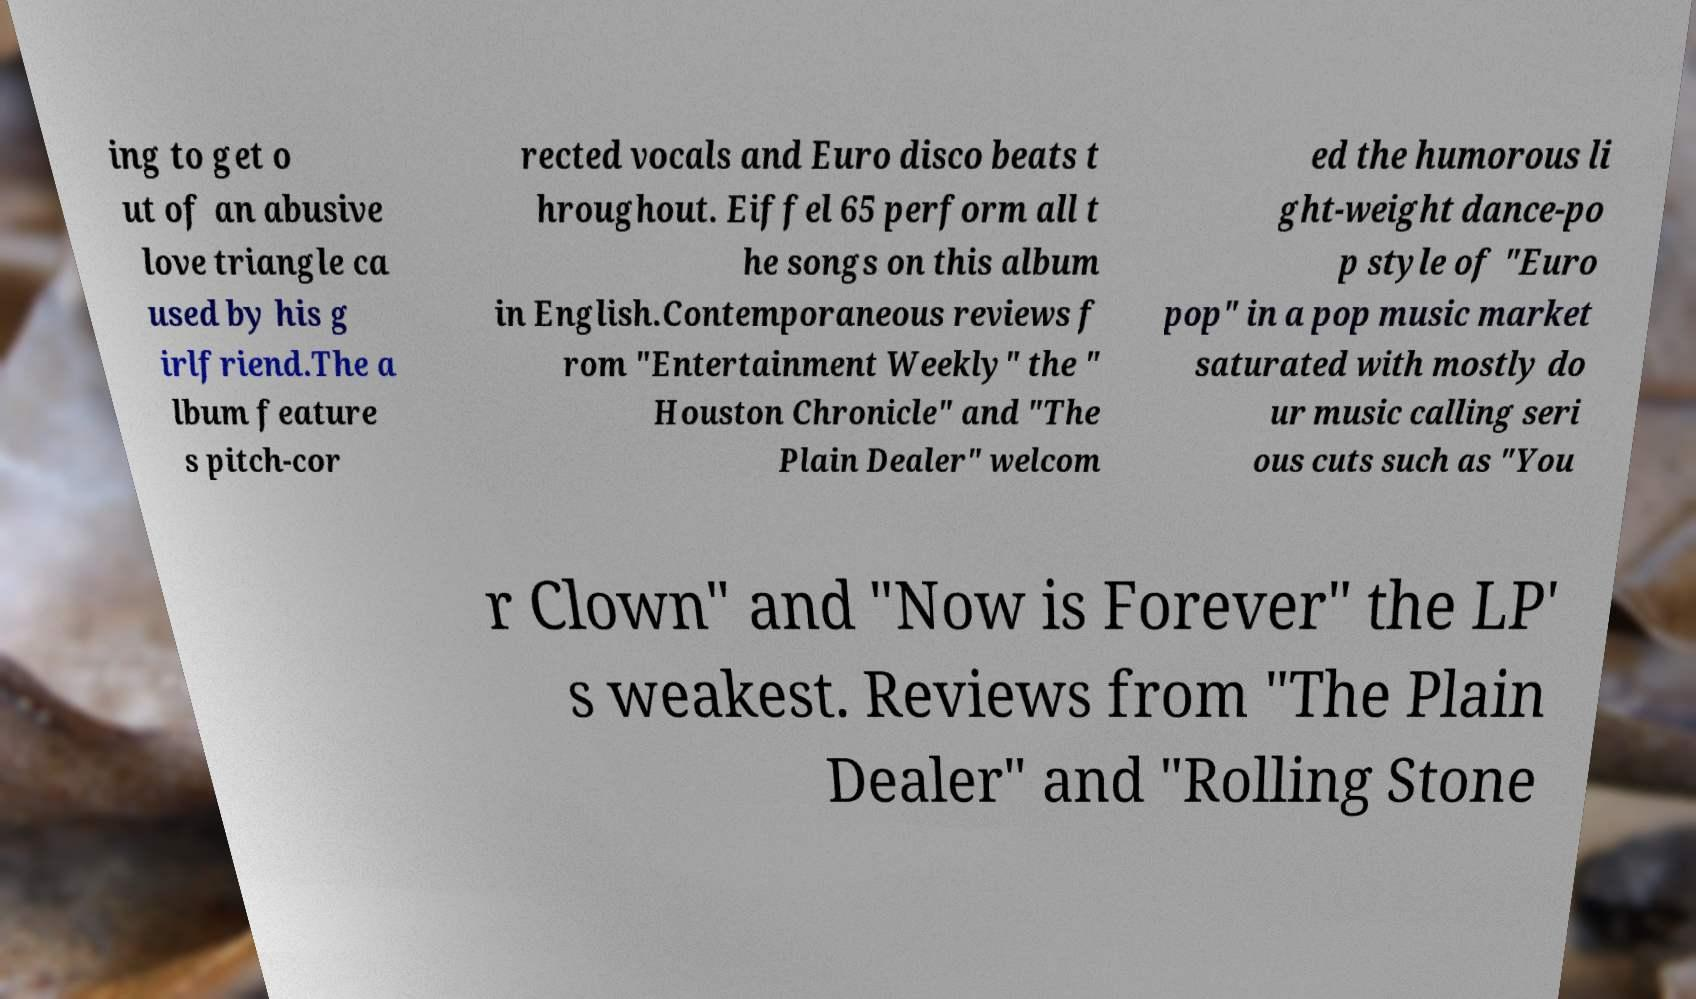Please identify and transcribe the text found in this image. ing to get o ut of an abusive love triangle ca used by his g irlfriend.The a lbum feature s pitch-cor rected vocals and Euro disco beats t hroughout. Eiffel 65 perform all t he songs on this album in English.Contemporaneous reviews f rom "Entertainment Weekly" the " Houston Chronicle" and "The Plain Dealer" welcom ed the humorous li ght-weight dance-po p style of "Euro pop" in a pop music market saturated with mostly do ur music calling seri ous cuts such as "You r Clown" and "Now is Forever" the LP' s weakest. Reviews from "The Plain Dealer" and "Rolling Stone 